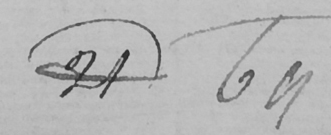Can you tell me what this handwritten text says? 21 69 